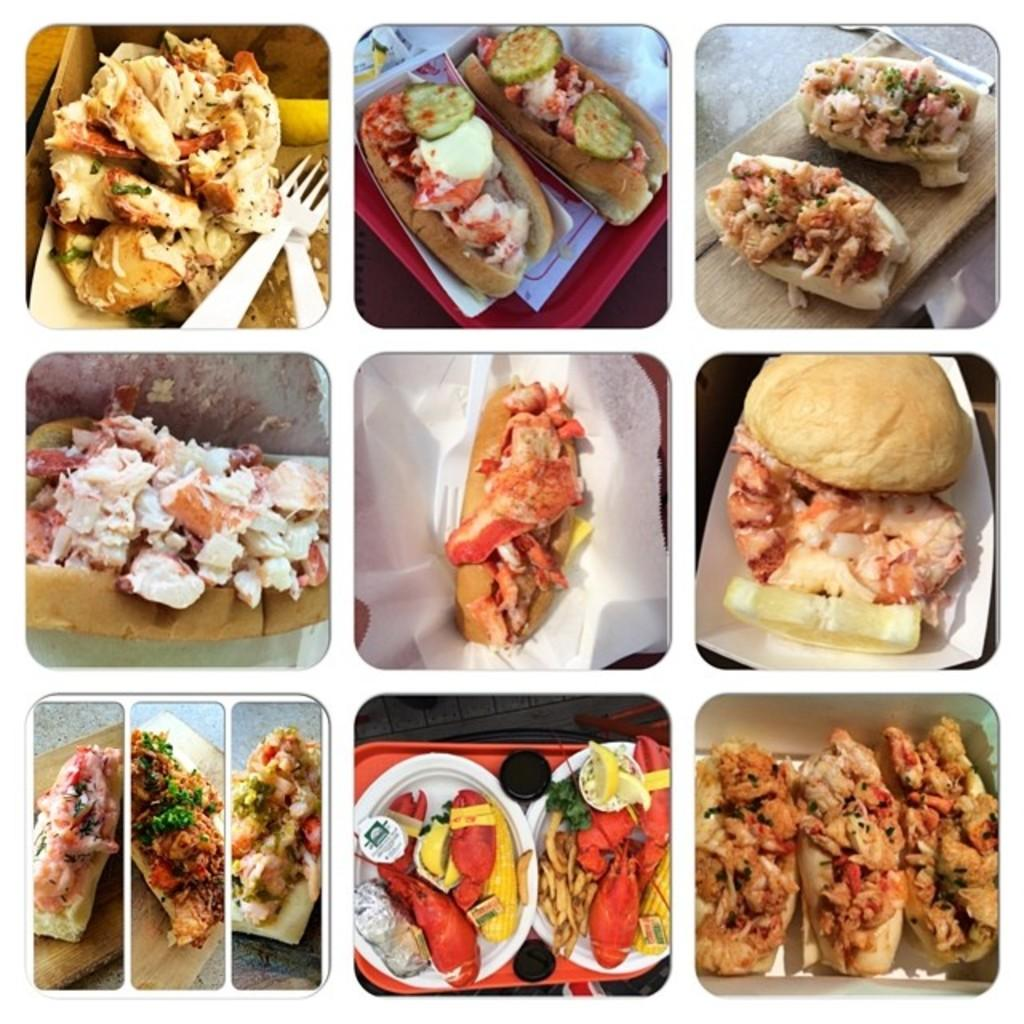What is the main subject of the image? The main subject of the image is a collage of pictures. What type of pictures are included in the collage? The collage includes pictures of food. How are the pictures of food arranged in the image? The food is placed on a surface in the collage. Can you tell me how many clovers are hidden in the food pictures? There are no clovers present in the food pictures; they are images of food items. 